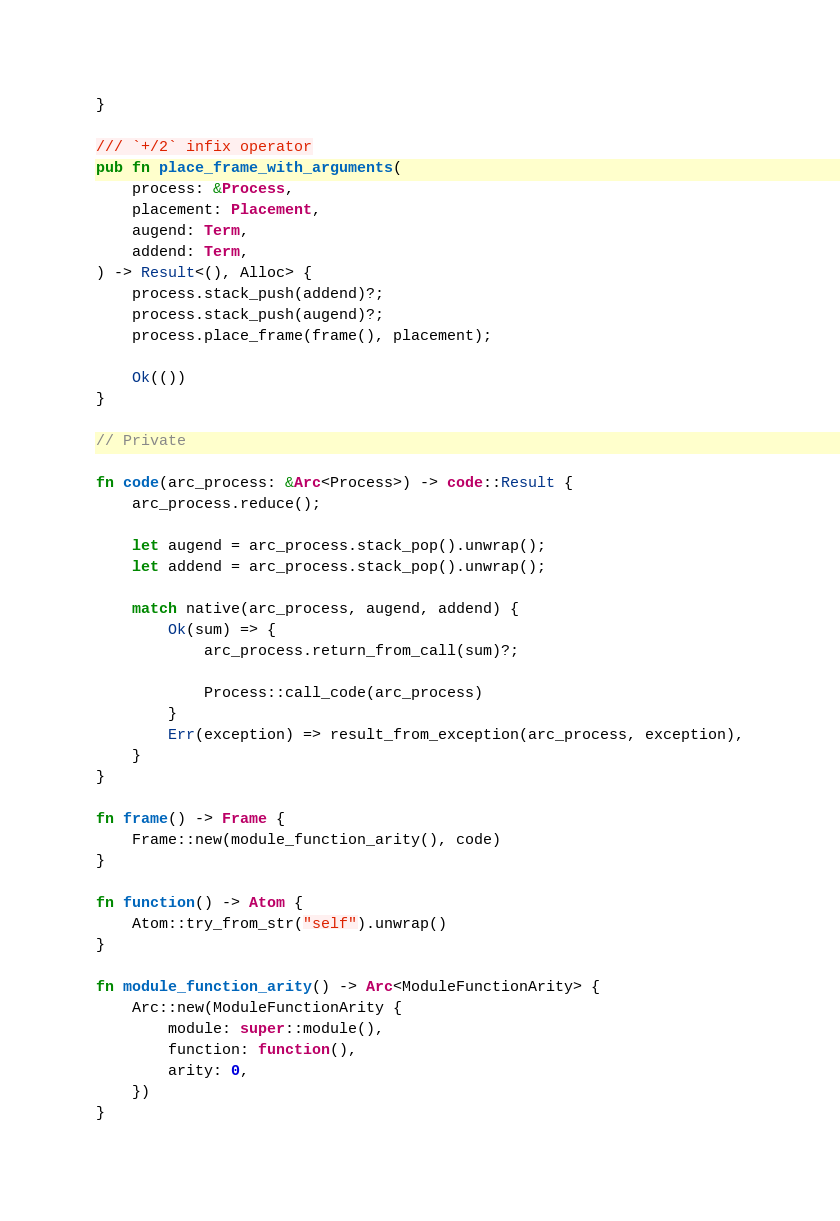Convert code to text. <code><loc_0><loc_0><loc_500><loc_500><_Rust_>}

/// `+/2` infix operator
pub fn place_frame_with_arguments(
    process: &Process,
    placement: Placement,
    augend: Term,
    addend: Term,
) -> Result<(), Alloc> {
    process.stack_push(addend)?;
    process.stack_push(augend)?;
    process.place_frame(frame(), placement);

    Ok(())
}

// Private

fn code(arc_process: &Arc<Process>) -> code::Result {
    arc_process.reduce();

    let augend = arc_process.stack_pop().unwrap();
    let addend = arc_process.stack_pop().unwrap();

    match native(arc_process, augend, addend) {
        Ok(sum) => {
            arc_process.return_from_call(sum)?;

            Process::call_code(arc_process)
        }
        Err(exception) => result_from_exception(arc_process, exception),
    }
}

fn frame() -> Frame {
    Frame::new(module_function_arity(), code)
}

fn function() -> Atom {
    Atom::try_from_str("self").unwrap()
}

fn module_function_arity() -> Arc<ModuleFunctionArity> {
    Arc::new(ModuleFunctionArity {
        module: super::module(),
        function: function(),
        arity: 0,
    })
}
</code> 